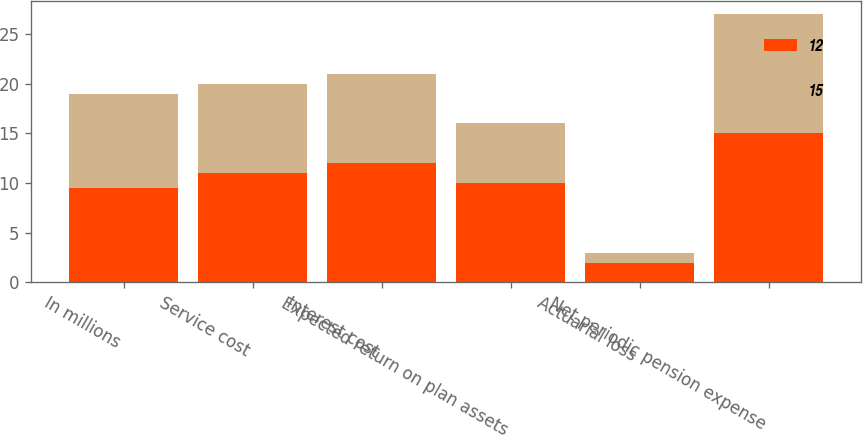Convert chart. <chart><loc_0><loc_0><loc_500><loc_500><stacked_bar_chart><ecel><fcel>In millions<fcel>Service cost<fcel>Interest cost<fcel>Expected return on plan assets<fcel>Actuarial loss<fcel>Net periodic pension expense<nl><fcel>12<fcel>9.5<fcel>11<fcel>12<fcel>10<fcel>2<fcel>15<nl><fcel>15<fcel>9.5<fcel>9<fcel>9<fcel>6<fcel>1<fcel>12<nl></chart> 